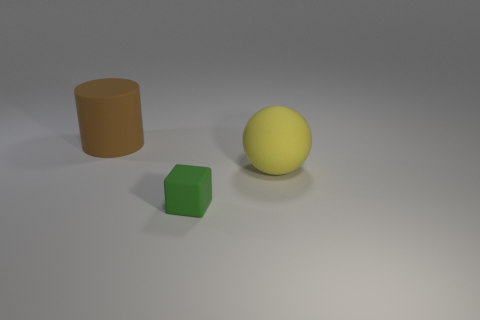Is there any other thing that is the same size as the green rubber cube?
Ensure brevity in your answer.  No. Are there any big rubber cylinders left of the matte cube?
Provide a short and direct response. Yes. There is a big object that is right of the object behind the thing to the right of the tiny rubber cube; what color is it?
Your answer should be very brief. Yellow. There is a yellow rubber object that is the same size as the cylinder; what is its shape?
Your response must be concise. Sphere. Is the number of brown rubber things greater than the number of large cyan objects?
Give a very brief answer. Yes. Are there any large rubber cylinders that are in front of the matte thing left of the tiny green object?
Provide a short and direct response. No. Is there any other thing that is the same shape as the small green matte object?
Your answer should be very brief. No. What is the color of the small thing that is made of the same material as the large brown cylinder?
Your response must be concise. Green. There is a big thing in front of the large object behind the large yellow rubber object; is there a large brown thing behind it?
Offer a very short reply. Yes. Are there fewer large cylinders in front of the large ball than large matte cylinders that are behind the small cube?
Provide a short and direct response. Yes. 